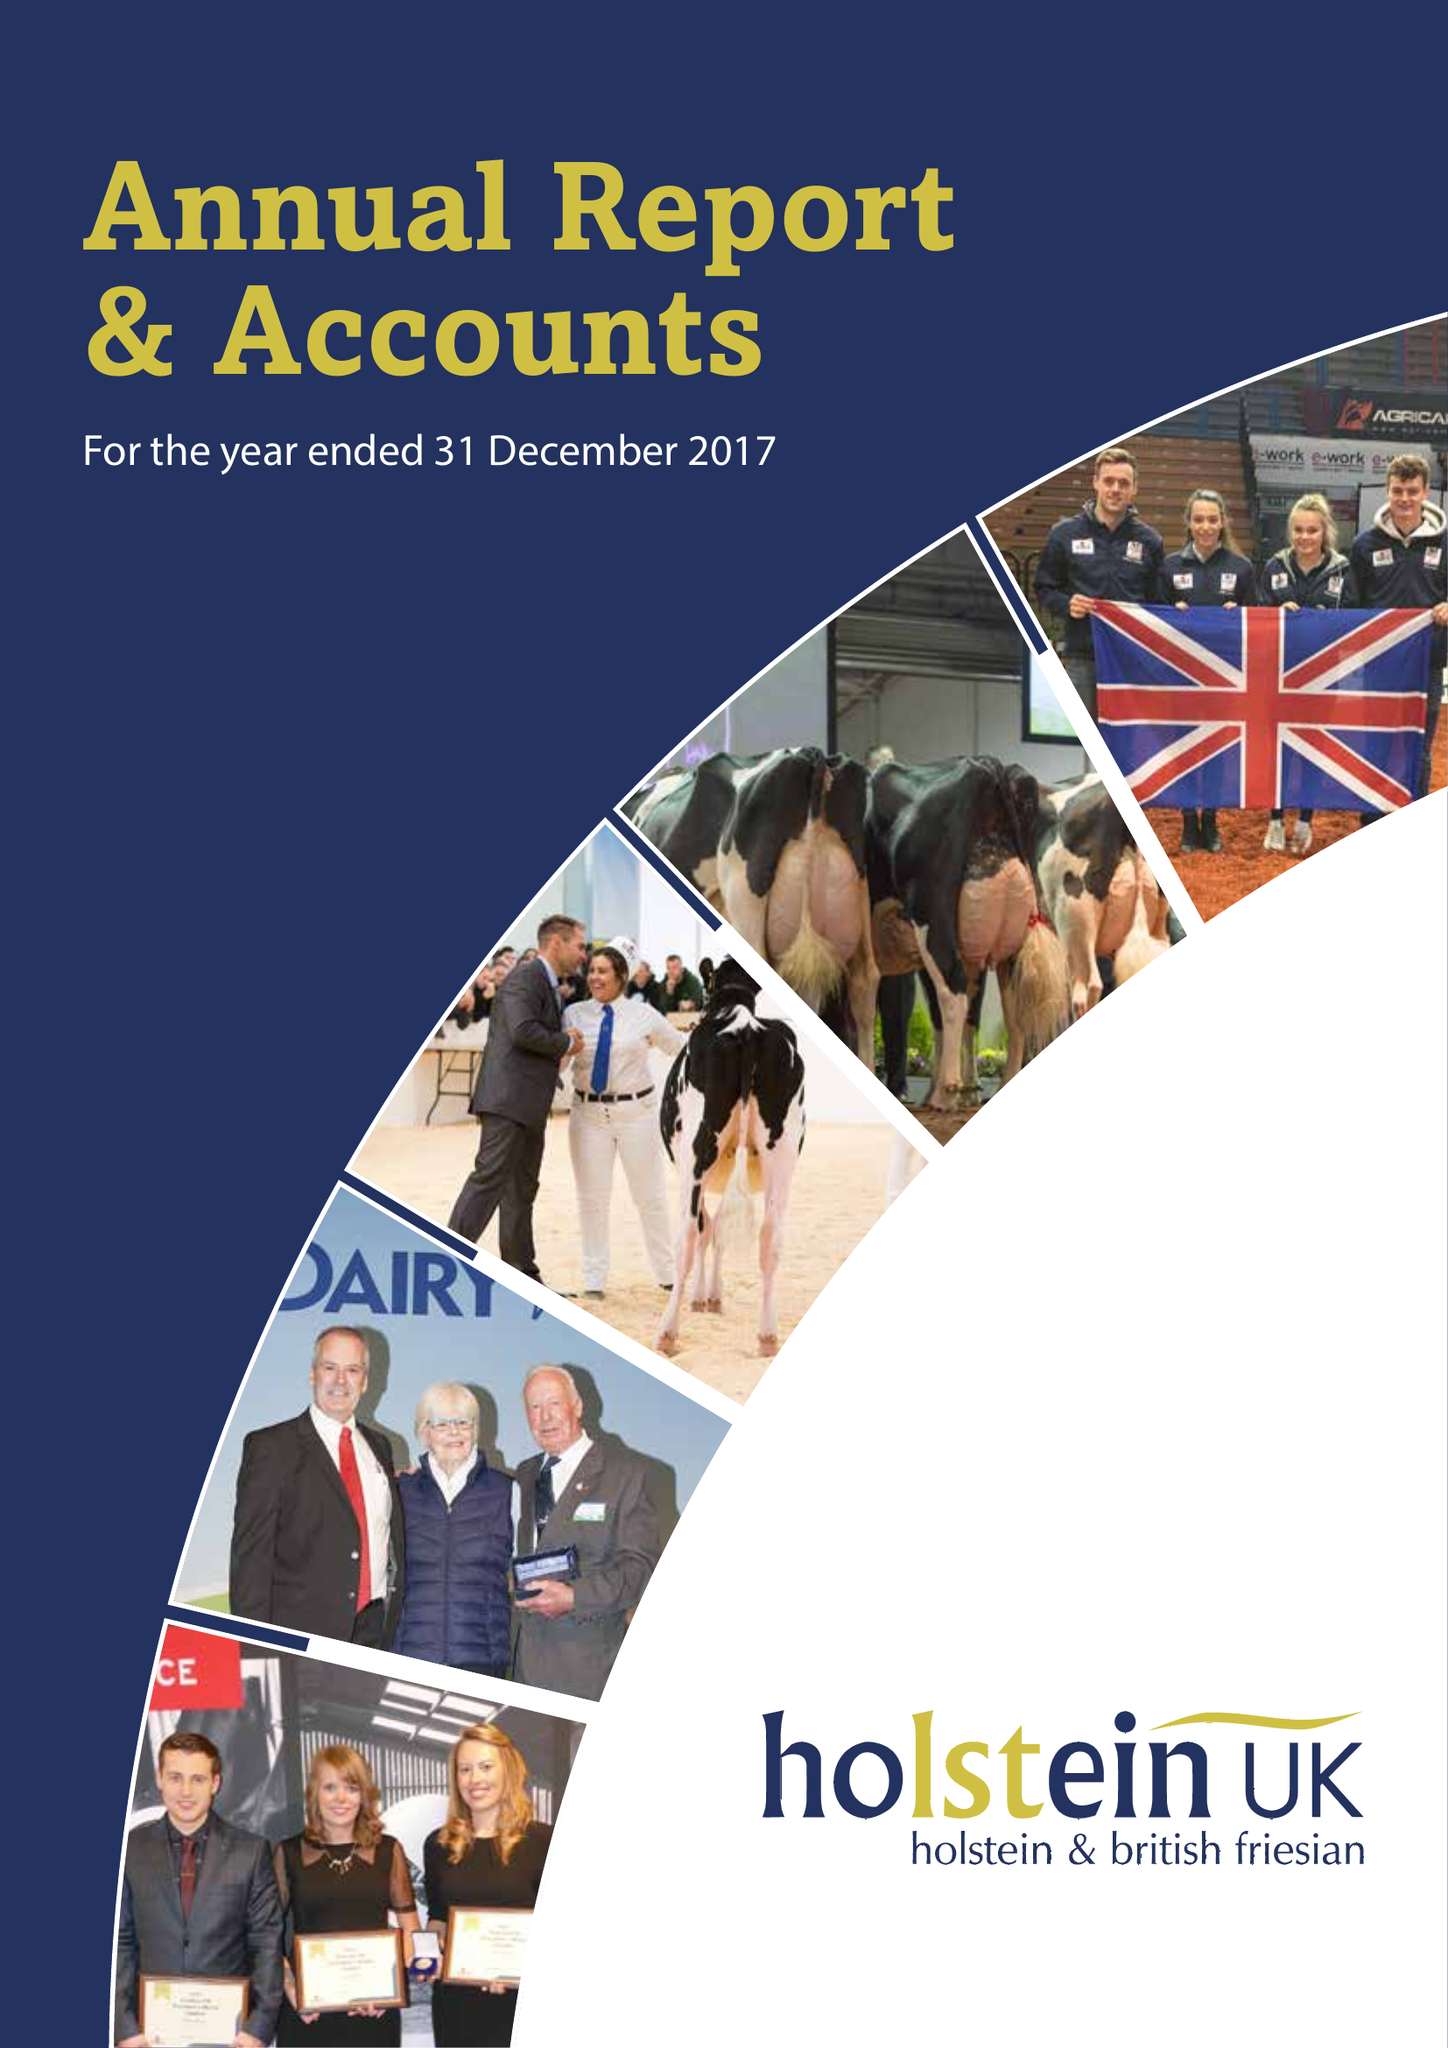What is the value for the charity_name?
Answer the question using a single word or phrase. Holstein Uk 